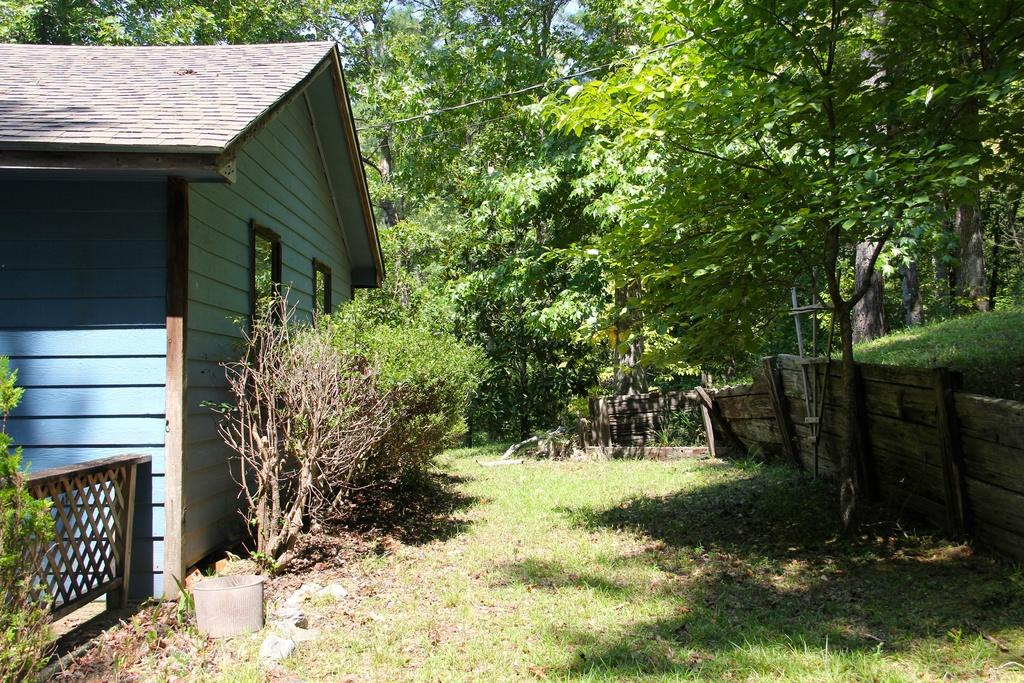What structure is located on the left side of the image? There is a house on the left side of the image. What type of vegetation is in front of the house? There are plants in front of the house. What type of fencing can be seen in the image? There is a wooden fencing on the surface of the grass. What can be seen in the background of the image? There are trees in the background of the image. Where is the kettle located in the image? There is no kettle present in the image. What type of class is being held in front of the house? There is no class being held in the image; it only shows a house, plants, wooden fencing, and trees. 